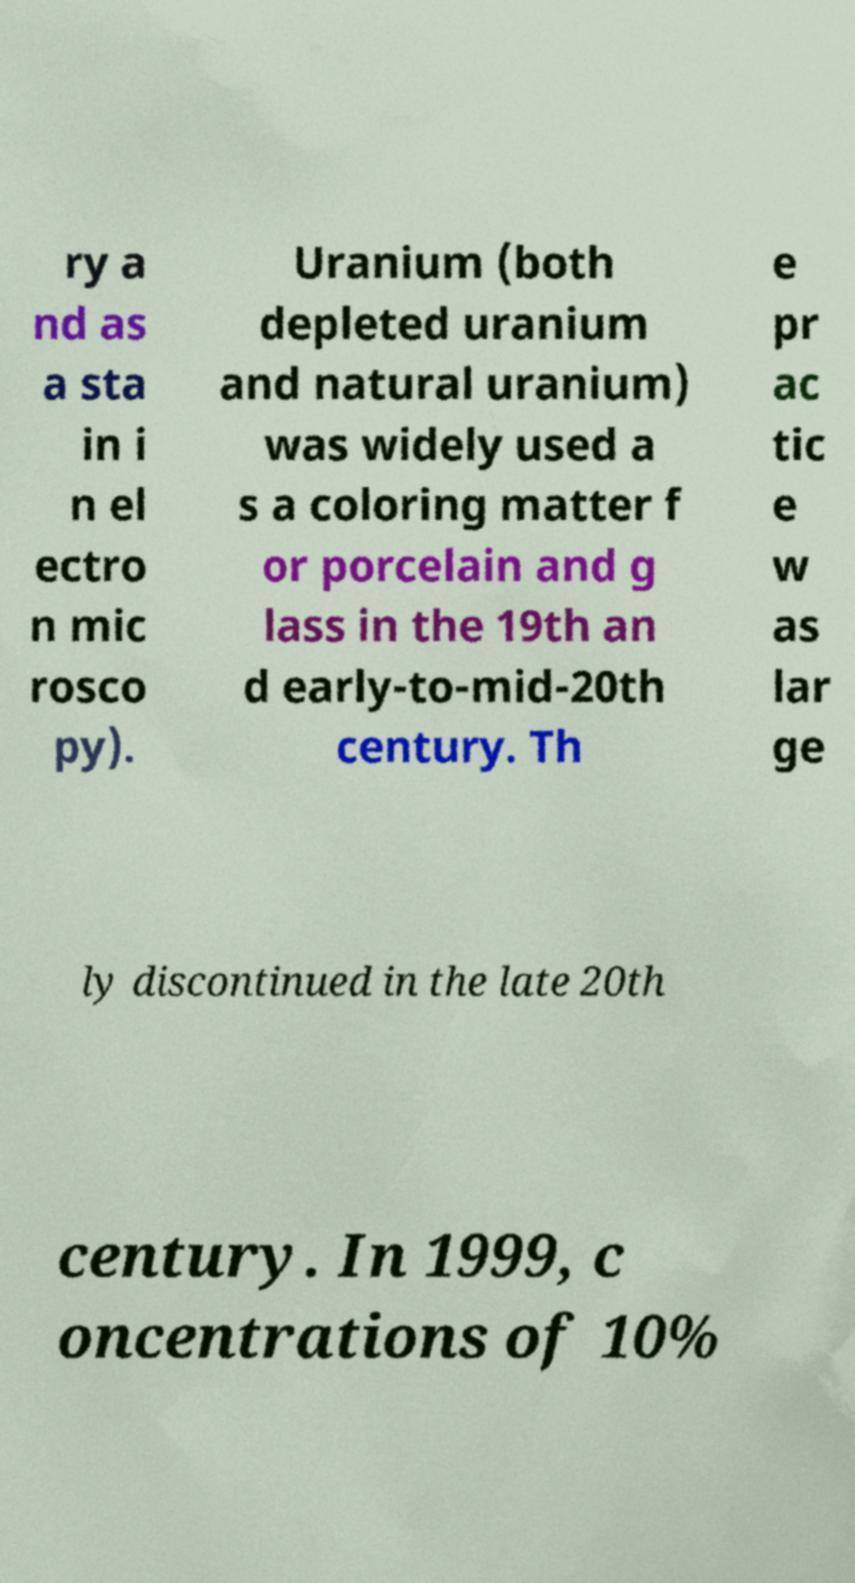Could you assist in decoding the text presented in this image and type it out clearly? ry a nd as a sta in i n el ectro n mic rosco py). Uranium (both depleted uranium and natural uranium) was widely used a s a coloring matter f or porcelain and g lass in the 19th an d early-to-mid-20th century. Th e pr ac tic e w as lar ge ly discontinued in the late 20th century. In 1999, c oncentrations of 10% 